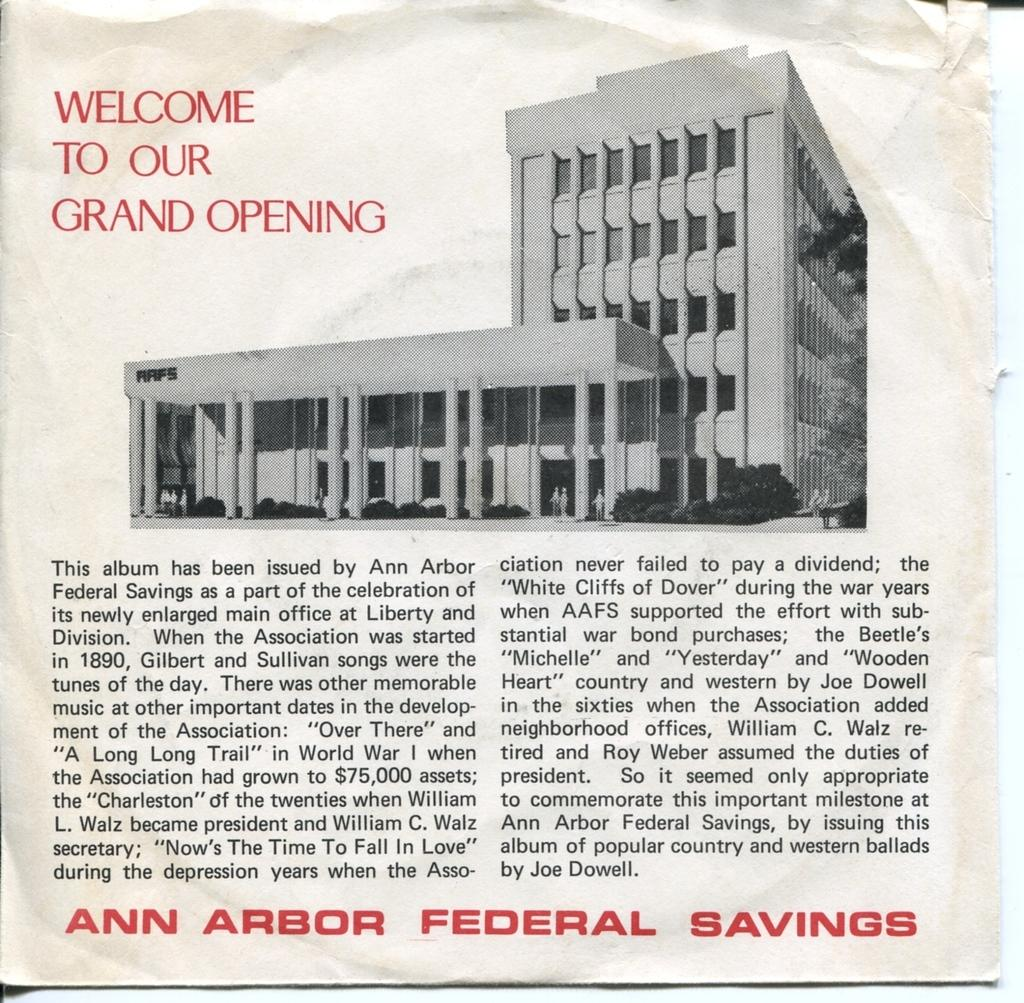What is depicted on the paper in the image? There is a picture of a building on the paper. What colors are used for the text on the paper? The text on the paper is in black and red color. What type of box is being judged in the image? There is no box or judging activity present in the image. Is there a hearing taking place in the image? There is no indication of a hearing or any legal proceedings in the image. 